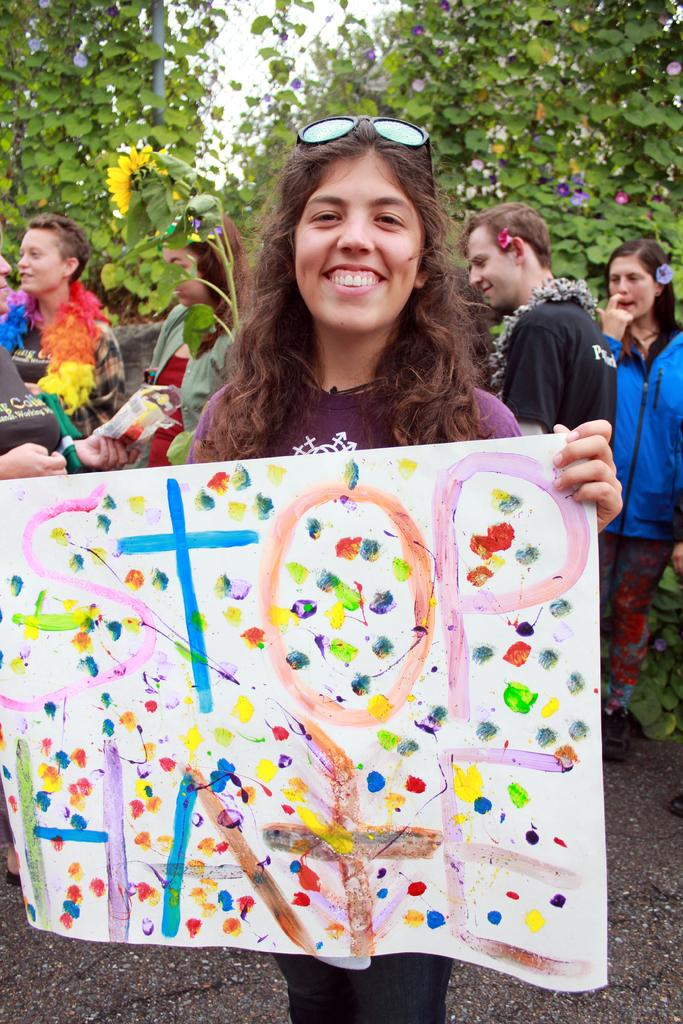Who is the main subject in the foreground of the image? There is a woman in the foreground of the image. What is the woman holding in her hand? The woman is holding a white sheet of paper. What is the woman's facial expression in the image? The woman has a smile on her face. What can be seen in the background of the image? There are people and trees in the background of the image. What type of wax is being used to create the woman's jeans in the image? There is no mention of wax or jeans in the image; the woman is holding a white sheet of paper. 